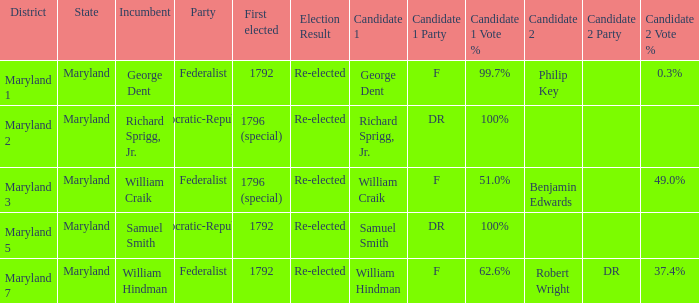 What is the result for the district Maryland 7? Re-elected. 